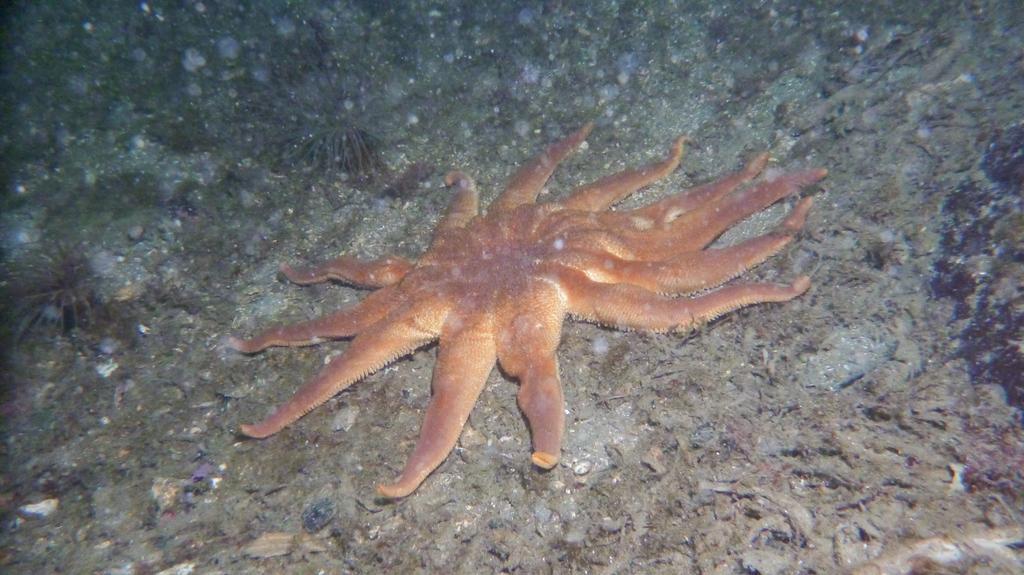How would you summarize this image in a sentence or two? In the center of the image there is a starfish present on some surface. 